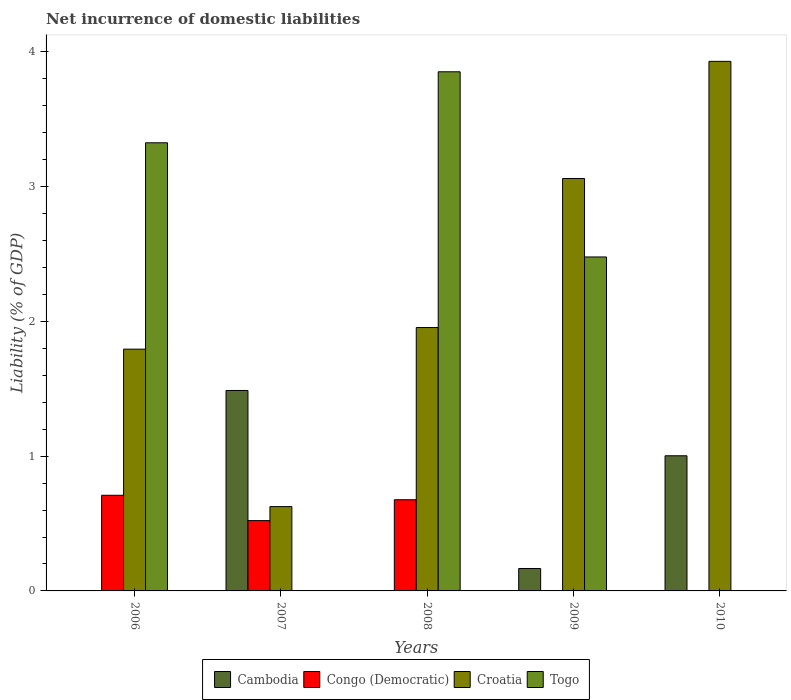How many groups of bars are there?
Give a very brief answer. 5. Are the number of bars per tick equal to the number of legend labels?
Give a very brief answer. No. What is the label of the 3rd group of bars from the left?
Keep it short and to the point. 2008. In how many cases, is the number of bars for a given year not equal to the number of legend labels?
Provide a succinct answer. 5. What is the net incurrence of domestic liabilities in Congo (Democratic) in 2006?
Keep it short and to the point. 0.71. Across all years, what is the maximum net incurrence of domestic liabilities in Cambodia?
Offer a terse response. 1.49. Across all years, what is the minimum net incurrence of domestic liabilities in Croatia?
Give a very brief answer. 0.63. What is the total net incurrence of domestic liabilities in Croatia in the graph?
Keep it short and to the point. 11.37. What is the difference between the net incurrence of domestic liabilities in Congo (Democratic) in 2006 and that in 2008?
Your answer should be compact. 0.03. What is the difference between the net incurrence of domestic liabilities in Togo in 2010 and the net incurrence of domestic liabilities in Congo (Democratic) in 2009?
Your answer should be compact. 0. What is the average net incurrence of domestic liabilities in Croatia per year?
Make the answer very short. 2.27. In the year 2006, what is the difference between the net incurrence of domestic liabilities in Congo (Democratic) and net incurrence of domestic liabilities in Croatia?
Keep it short and to the point. -1.08. What is the ratio of the net incurrence of domestic liabilities in Croatia in 2006 to that in 2007?
Provide a short and direct response. 2.87. Is the net incurrence of domestic liabilities in Congo (Democratic) in 2006 less than that in 2008?
Your answer should be compact. No. Is the difference between the net incurrence of domestic liabilities in Congo (Democratic) in 2007 and 2008 greater than the difference between the net incurrence of domestic liabilities in Croatia in 2007 and 2008?
Your response must be concise. Yes. What is the difference between the highest and the second highest net incurrence of domestic liabilities in Cambodia?
Your answer should be very brief. 0.48. What is the difference between the highest and the lowest net incurrence of domestic liabilities in Croatia?
Keep it short and to the point. 3.3. In how many years, is the net incurrence of domestic liabilities in Croatia greater than the average net incurrence of domestic liabilities in Croatia taken over all years?
Give a very brief answer. 2. Is the sum of the net incurrence of domestic liabilities in Croatia in 2006 and 2009 greater than the maximum net incurrence of domestic liabilities in Cambodia across all years?
Offer a terse response. Yes. Is it the case that in every year, the sum of the net incurrence of domestic liabilities in Cambodia and net incurrence of domestic liabilities in Togo is greater than the sum of net incurrence of domestic liabilities in Congo (Democratic) and net incurrence of domestic liabilities in Croatia?
Your answer should be very brief. No. Is it the case that in every year, the sum of the net incurrence of domestic liabilities in Croatia and net incurrence of domestic liabilities in Togo is greater than the net incurrence of domestic liabilities in Cambodia?
Your answer should be very brief. No. How many bars are there?
Offer a very short reply. 14. Are all the bars in the graph horizontal?
Your response must be concise. No. How many years are there in the graph?
Your answer should be very brief. 5. Does the graph contain grids?
Offer a very short reply. No. Where does the legend appear in the graph?
Ensure brevity in your answer.  Bottom center. What is the title of the graph?
Keep it short and to the point. Net incurrence of domestic liabilities. What is the label or title of the X-axis?
Provide a short and direct response. Years. What is the label or title of the Y-axis?
Provide a short and direct response. Liability (% of GDP). What is the Liability (% of GDP) in Congo (Democratic) in 2006?
Your answer should be very brief. 0.71. What is the Liability (% of GDP) in Croatia in 2006?
Provide a succinct answer. 1.79. What is the Liability (% of GDP) in Togo in 2006?
Provide a succinct answer. 3.33. What is the Liability (% of GDP) of Cambodia in 2007?
Offer a terse response. 1.49. What is the Liability (% of GDP) in Congo (Democratic) in 2007?
Keep it short and to the point. 0.52. What is the Liability (% of GDP) of Croatia in 2007?
Make the answer very short. 0.63. What is the Liability (% of GDP) of Togo in 2007?
Your answer should be compact. 0. What is the Liability (% of GDP) in Congo (Democratic) in 2008?
Your answer should be compact. 0.68. What is the Liability (% of GDP) of Croatia in 2008?
Offer a very short reply. 1.95. What is the Liability (% of GDP) in Togo in 2008?
Your answer should be very brief. 3.85. What is the Liability (% of GDP) in Cambodia in 2009?
Offer a very short reply. 0.17. What is the Liability (% of GDP) in Croatia in 2009?
Your response must be concise. 3.06. What is the Liability (% of GDP) in Togo in 2009?
Ensure brevity in your answer.  2.48. What is the Liability (% of GDP) in Cambodia in 2010?
Provide a succinct answer. 1. What is the Liability (% of GDP) in Croatia in 2010?
Your answer should be compact. 3.93. Across all years, what is the maximum Liability (% of GDP) in Cambodia?
Give a very brief answer. 1.49. Across all years, what is the maximum Liability (% of GDP) in Congo (Democratic)?
Ensure brevity in your answer.  0.71. Across all years, what is the maximum Liability (% of GDP) in Croatia?
Offer a very short reply. 3.93. Across all years, what is the maximum Liability (% of GDP) in Togo?
Your answer should be very brief. 3.85. Across all years, what is the minimum Liability (% of GDP) of Congo (Democratic)?
Your answer should be very brief. 0. Across all years, what is the minimum Liability (% of GDP) of Croatia?
Make the answer very short. 0.63. Across all years, what is the minimum Liability (% of GDP) in Togo?
Provide a succinct answer. 0. What is the total Liability (% of GDP) in Cambodia in the graph?
Keep it short and to the point. 2.66. What is the total Liability (% of GDP) in Congo (Democratic) in the graph?
Give a very brief answer. 1.91. What is the total Liability (% of GDP) of Croatia in the graph?
Keep it short and to the point. 11.37. What is the total Liability (% of GDP) of Togo in the graph?
Provide a succinct answer. 9.66. What is the difference between the Liability (% of GDP) of Congo (Democratic) in 2006 and that in 2007?
Provide a succinct answer. 0.19. What is the difference between the Liability (% of GDP) of Croatia in 2006 and that in 2007?
Keep it short and to the point. 1.17. What is the difference between the Liability (% of GDP) of Congo (Democratic) in 2006 and that in 2008?
Offer a very short reply. 0.03. What is the difference between the Liability (% of GDP) of Croatia in 2006 and that in 2008?
Your answer should be very brief. -0.16. What is the difference between the Liability (% of GDP) of Togo in 2006 and that in 2008?
Give a very brief answer. -0.53. What is the difference between the Liability (% of GDP) in Croatia in 2006 and that in 2009?
Offer a very short reply. -1.27. What is the difference between the Liability (% of GDP) in Togo in 2006 and that in 2009?
Your response must be concise. 0.85. What is the difference between the Liability (% of GDP) of Croatia in 2006 and that in 2010?
Your answer should be compact. -2.14. What is the difference between the Liability (% of GDP) in Congo (Democratic) in 2007 and that in 2008?
Your response must be concise. -0.15. What is the difference between the Liability (% of GDP) of Croatia in 2007 and that in 2008?
Ensure brevity in your answer.  -1.33. What is the difference between the Liability (% of GDP) in Cambodia in 2007 and that in 2009?
Offer a terse response. 1.32. What is the difference between the Liability (% of GDP) in Croatia in 2007 and that in 2009?
Offer a terse response. -2.44. What is the difference between the Liability (% of GDP) in Cambodia in 2007 and that in 2010?
Give a very brief answer. 0.48. What is the difference between the Liability (% of GDP) in Croatia in 2007 and that in 2010?
Offer a very short reply. -3.3. What is the difference between the Liability (% of GDP) in Croatia in 2008 and that in 2009?
Your answer should be very brief. -1.11. What is the difference between the Liability (% of GDP) in Togo in 2008 and that in 2009?
Provide a short and direct response. 1.37. What is the difference between the Liability (% of GDP) in Croatia in 2008 and that in 2010?
Give a very brief answer. -1.98. What is the difference between the Liability (% of GDP) of Cambodia in 2009 and that in 2010?
Offer a terse response. -0.84. What is the difference between the Liability (% of GDP) of Croatia in 2009 and that in 2010?
Give a very brief answer. -0.87. What is the difference between the Liability (% of GDP) in Congo (Democratic) in 2006 and the Liability (% of GDP) in Croatia in 2007?
Provide a short and direct response. 0.08. What is the difference between the Liability (% of GDP) of Congo (Democratic) in 2006 and the Liability (% of GDP) of Croatia in 2008?
Ensure brevity in your answer.  -1.24. What is the difference between the Liability (% of GDP) of Congo (Democratic) in 2006 and the Liability (% of GDP) of Togo in 2008?
Keep it short and to the point. -3.14. What is the difference between the Liability (% of GDP) of Croatia in 2006 and the Liability (% of GDP) of Togo in 2008?
Give a very brief answer. -2.06. What is the difference between the Liability (% of GDP) of Congo (Democratic) in 2006 and the Liability (% of GDP) of Croatia in 2009?
Give a very brief answer. -2.35. What is the difference between the Liability (% of GDP) in Congo (Democratic) in 2006 and the Liability (% of GDP) in Togo in 2009?
Your answer should be compact. -1.77. What is the difference between the Liability (% of GDP) in Croatia in 2006 and the Liability (% of GDP) in Togo in 2009?
Ensure brevity in your answer.  -0.68. What is the difference between the Liability (% of GDP) of Congo (Democratic) in 2006 and the Liability (% of GDP) of Croatia in 2010?
Give a very brief answer. -3.22. What is the difference between the Liability (% of GDP) in Cambodia in 2007 and the Liability (% of GDP) in Congo (Democratic) in 2008?
Offer a very short reply. 0.81. What is the difference between the Liability (% of GDP) of Cambodia in 2007 and the Liability (% of GDP) of Croatia in 2008?
Ensure brevity in your answer.  -0.47. What is the difference between the Liability (% of GDP) in Cambodia in 2007 and the Liability (% of GDP) in Togo in 2008?
Give a very brief answer. -2.37. What is the difference between the Liability (% of GDP) in Congo (Democratic) in 2007 and the Liability (% of GDP) in Croatia in 2008?
Make the answer very short. -1.43. What is the difference between the Liability (% of GDP) of Congo (Democratic) in 2007 and the Liability (% of GDP) of Togo in 2008?
Provide a succinct answer. -3.33. What is the difference between the Liability (% of GDP) of Croatia in 2007 and the Liability (% of GDP) of Togo in 2008?
Keep it short and to the point. -3.23. What is the difference between the Liability (% of GDP) in Cambodia in 2007 and the Liability (% of GDP) in Croatia in 2009?
Offer a terse response. -1.57. What is the difference between the Liability (% of GDP) of Cambodia in 2007 and the Liability (% of GDP) of Togo in 2009?
Give a very brief answer. -0.99. What is the difference between the Liability (% of GDP) in Congo (Democratic) in 2007 and the Liability (% of GDP) in Croatia in 2009?
Your answer should be compact. -2.54. What is the difference between the Liability (% of GDP) in Congo (Democratic) in 2007 and the Liability (% of GDP) in Togo in 2009?
Ensure brevity in your answer.  -1.96. What is the difference between the Liability (% of GDP) of Croatia in 2007 and the Liability (% of GDP) of Togo in 2009?
Your answer should be very brief. -1.85. What is the difference between the Liability (% of GDP) of Cambodia in 2007 and the Liability (% of GDP) of Croatia in 2010?
Provide a short and direct response. -2.44. What is the difference between the Liability (% of GDP) in Congo (Democratic) in 2007 and the Liability (% of GDP) in Croatia in 2010?
Your answer should be compact. -3.41. What is the difference between the Liability (% of GDP) of Congo (Democratic) in 2008 and the Liability (% of GDP) of Croatia in 2009?
Your response must be concise. -2.38. What is the difference between the Liability (% of GDP) of Congo (Democratic) in 2008 and the Liability (% of GDP) of Togo in 2009?
Offer a terse response. -1.8. What is the difference between the Liability (% of GDP) of Croatia in 2008 and the Liability (% of GDP) of Togo in 2009?
Keep it short and to the point. -0.52. What is the difference between the Liability (% of GDP) of Congo (Democratic) in 2008 and the Liability (% of GDP) of Croatia in 2010?
Your response must be concise. -3.25. What is the difference between the Liability (% of GDP) of Cambodia in 2009 and the Liability (% of GDP) of Croatia in 2010?
Make the answer very short. -3.76. What is the average Liability (% of GDP) of Cambodia per year?
Ensure brevity in your answer.  0.53. What is the average Liability (% of GDP) of Congo (Democratic) per year?
Make the answer very short. 0.38. What is the average Liability (% of GDP) in Croatia per year?
Your answer should be compact. 2.27. What is the average Liability (% of GDP) in Togo per year?
Your answer should be very brief. 1.93. In the year 2006, what is the difference between the Liability (% of GDP) of Congo (Democratic) and Liability (% of GDP) of Croatia?
Provide a short and direct response. -1.08. In the year 2006, what is the difference between the Liability (% of GDP) of Congo (Democratic) and Liability (% of GDP) of Togo?
Offer a very short reply. -2.62. In the year 2006, what is the difference between the Liability (% of GDP) in Croatia and Liability (% of GDP) in Togo?
Your response must be concise. -1.53. In the year 2007, what is the difference between the Liability (% of GDP) of Cambodia and Liability (% of GDP) of Congo (Democratic)?
Your answer should be compact. 0.97. In the year 2007, what is the difference between the Liability (% of GDP) of Cambodia and Liability (% of GDP) of Croatia?
Offer a very short reply. 0.86. In the year 2007, what is the difference between the Liability (% of GDP) in Congo (Democratic) and Liability (% of GDP) in Croatia?
Your response must be concise. -0.1. In the year 2008, what is the difference between the Liability (% of GDP) in Congo (Democratic) and Liability (% of GDP) in Croatia?
Your answer should be very brief. -1.28. In the year 2008, what is the difference between the Liability (% of GDP) of Congo (Democratic) and Liability (% of GDP) of Togo?
Offer a very short reply. -3.18. In the year 2008, what is the difference between the Liability (% of GDP) of Croatia and Liability (% of GDP) of Togo?
Keep it short and to the point. -1.9. In the year 2009, what is the difference between the Liability (% of GDP) of Cambodia and Liability (% of GDP) of Croatia?
Keep it short and to the point. -2.89. In the year 2009, what is the difference between the Liability (% of GDP) of Cambodia and Liability (% of GDP) of Togo?
Offer a very short reply. -2.31. In the year 2009, what is the difference between the Liability (% of GDP) of Croatia and Liability (% of GDP) of Togo?
Your answer should be compact. 0.58. In the year 2010, what is the difference between the Liability (% of GDP) of Cambodia and Liability (% of GDP) of Croatia?
Offer a very short reply. -2.93. What is the ratio of the Liability (% of GDP) of Congo (Democratic) in 2006 to that in 2007?
Your answer should be compact. 1.36. What is the ratio of the Liability (% of GDP) of Croatia in 2006 to that in 2007?
Your response must be concise. 2.87. What is the ratio of the Liability (% of GDP) in Congo (Democratic) in 2006 to that in 2008?
Offer a terse response. 1.05. What is the ratio of the Liability (% of GDP) in Croatia in 2006 to that in 2008?
Your response must be concise. 0.92. What is the ratio of the Liability (% of GDP) of Togo in 2006 to that in 2008?
Your answer should be very brief. 0.86. What is the ratio of the Liability (% of GDP) in Croatia in 2006 to that in 2009?
Ensure brevity in your answer.  0.59. What is the ratio of the Liability (% of GDP) in Togo in 2006 to that in 2009?
Make the answer very short. 1.34. What is the ratio of the Liability (% of GDP) in Croatia in 2006 to that in 2010?
Your answer should be compact. 0.46. What is the ratio of the Liability (% of GDP) of Congo (Democratic) in 2007 to that in 2008?
Keep it short and to the point. 0.77. What is the ratio of the Liability (% of GDP) in Croatia in 2007 to that in 2008?
Keep it short and to the point. 0.32. What is the ratio of the Liability (% of GDP) in Cambodia in 2007 to that in 2009?
Offer a very short reply. 8.93. What is the ratio of the Liability (% of GDP) of Croatia in 2007 to that in 2009?
Give a very brief answer. 0.2. What is the ratio of the Liability (% of GDP) in Cambodia in 2007 to that in 2010?
Make the answer very short. 1.48. What is the ratio of the Liability (% of GDP) in Croatia in 2007 to that in 2010?
Provide a short and direct response. 0.16. What is the ratio of the Liability (% of GDP) of Croatia in 2008 to that in 2009?
Provide a succinct answer. 0.64. What is the ratio of the Liability (% of GDP) of Togo in 2008 to that in 2009?
Keep it short and to the point. 1.55. What is the ratio of the Liability (% of GDP) in Croatia in 2008 to that in 2010?
Offer a terse response. 0.5. What is the ratio of the Liability (% of GDP) in Cambodia in 2009 to that in 2010?
Ensure brevity in your answer.  0.17. What is the ratio of the Liability (% of GDP) in Croatia in 2009 to that in 2010?
Give a very brief answer. 0.78. What is the difference between the highest and the second highest Liability (% of GDP) in Cambodia?
Your answer should be compact. 0.48. What is the difference between the highest and the second highest Liability (% of GDP) of Congo (Democratic)?
Keep it short and to the point. 0.03. What is the difference between the highest and the second highest Liability (% of GDP) in Croatia?
Offer a very short reply. 0.87. What is the difference between the highest and the second highest Liability (% of GDP) in Togo?
Give a very brief answer. 0.53. What is the difference between the highest and the lowest Liability (% of GDP) of Cambodia?
Keep it short and to the point. 1.49. What is the difference between the highest and the lowest Liability (% of GDP) in Congo (Democratic)?
Give a very brief answer. 0.71. What is the difference between the highest and the lowest Liability (% of GDP) of Croatia?
Ensure brevity in your answer.  3.3. What is the difference between the highest and the lowest Liability (% of GDP) in Togo?
Make the answer very short. 3.85. 